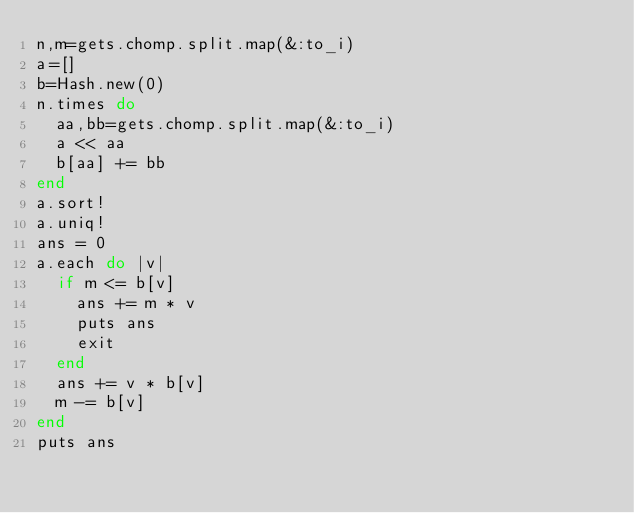Convert code to text. <code><loc_0><loc_0><loc_500><loc_500><_Ruby_>n,m=gets.chomp.split.map(&:to_i)
a=[]
b=Hash.new(0)
n.times do
  aa,bb=gets.chomp.split.map(&:to_i)
  a << aa
  b[aa] += bb
end
a.sort!
a.uniq!
ans = 0
a.each do |v|
  if m <= b[v]
    ans += m * v
    puts ans
    exit
  end
  ans += v * b[v]
  m -= b[v]
end
puts ans


</code> 